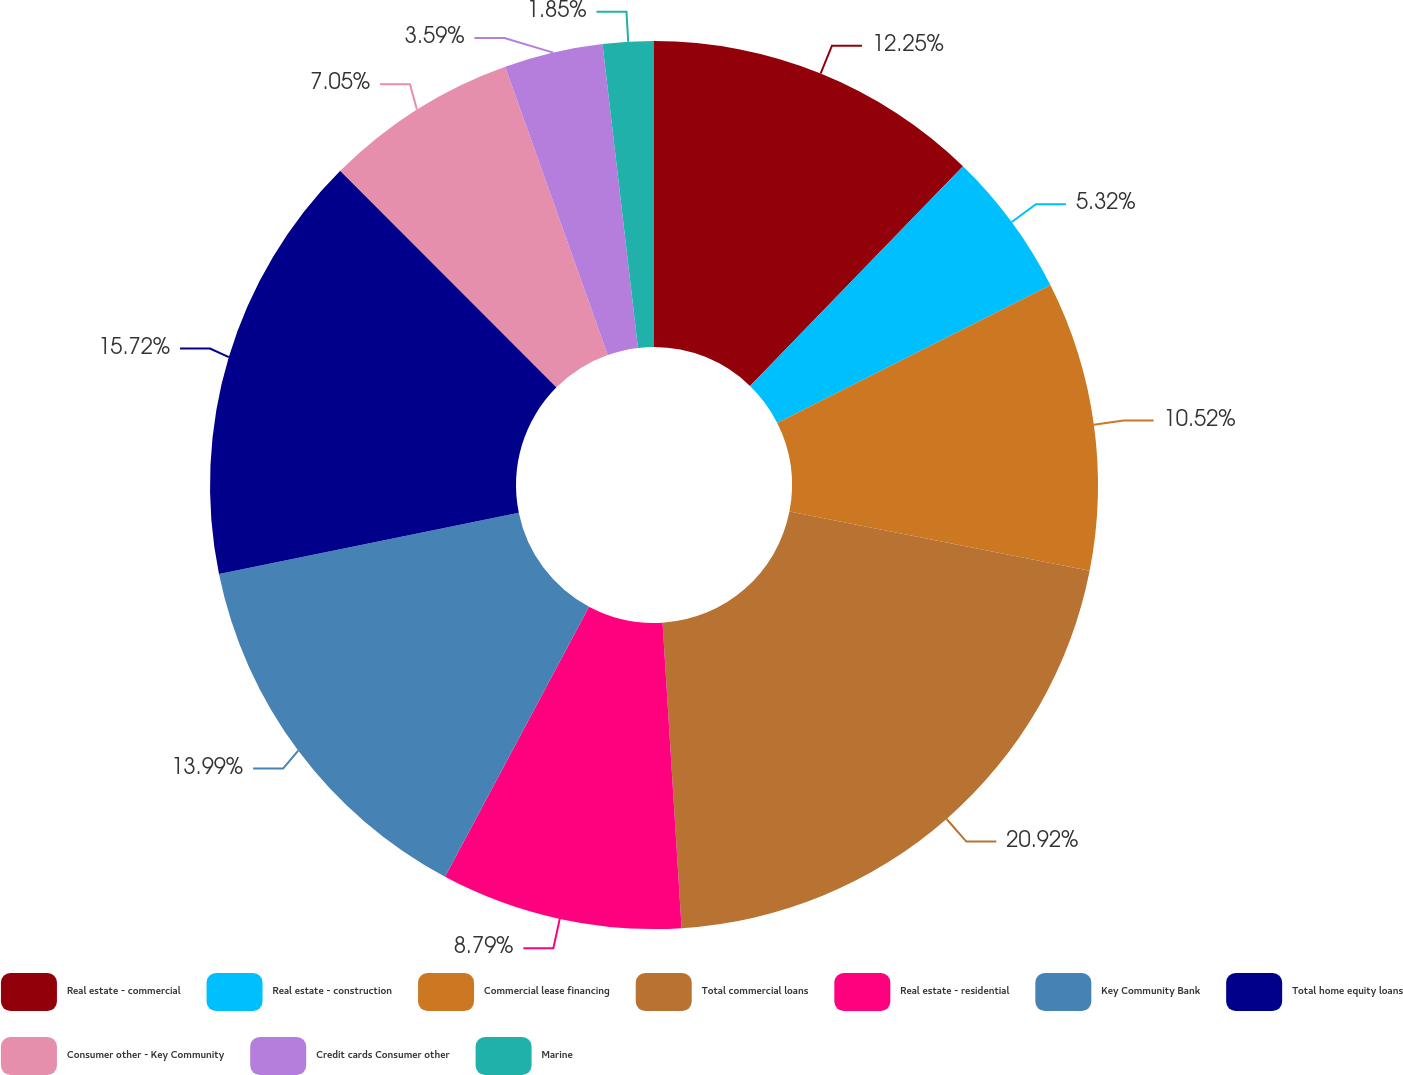<chart> <loc_0><loc_0><loc_500><loc_500><pie_chart><fcel>Real estate - commercial<fcel>Real estate - construction<fcel>Commercial lease financing<fcel>Total commercial loans<fcel>Real estate - residential<fcel>Key Community Bank<fcel>Total home equity loans<fcel>Consumer other - Key Community<fcel>Credit cards Consumer other<fcel>Marine<nl><fcel>12.25%<fcel>5.32%<fcel>10.52%<fcel>20.92%<fcel>8.79%<fcel>13.99%<fcel>15.72%<fcel>7.05%<fcel>3.59%<fcel>1.85%<nl></chart> 